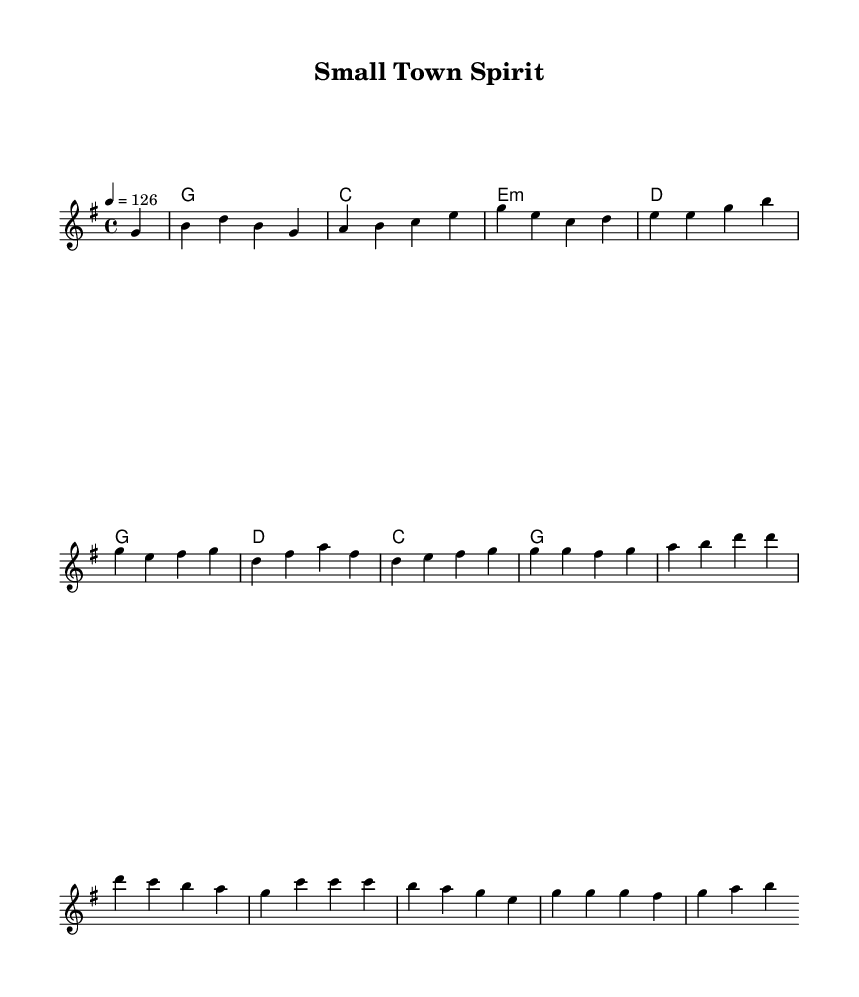What is the key signature of this music? The key signature is G major, which has one sharp (F#).
Answer: G major What is the time signature of this music? The time signature is 4/4, indicating four beats in each measure.
Answer: 4/4 What is the tempo of this music? The tempo marking indicates a speed of 126 beats per minute.
Answer: 126 How many measures are in the melody? The melody consists of 8 measures, as indicated by the separation of phrases by bars.
Answer: 8 measures What musical form does this piece primarily follow? The piece follows a verse-chorus structure, commonly used in country rock music for storytelling.
Answer: Verse-chorus What is the first word of the chorus? The first word of the chorus is "Raise," signaling the shift in thematic content.
Answer: Raise What instrument would typically accompany this piece in a country rock setting? A common accompaniment instrument in country rock would be an acoustic guitar, known for its rhythm and texture.
Answer: Acoustic guitar 